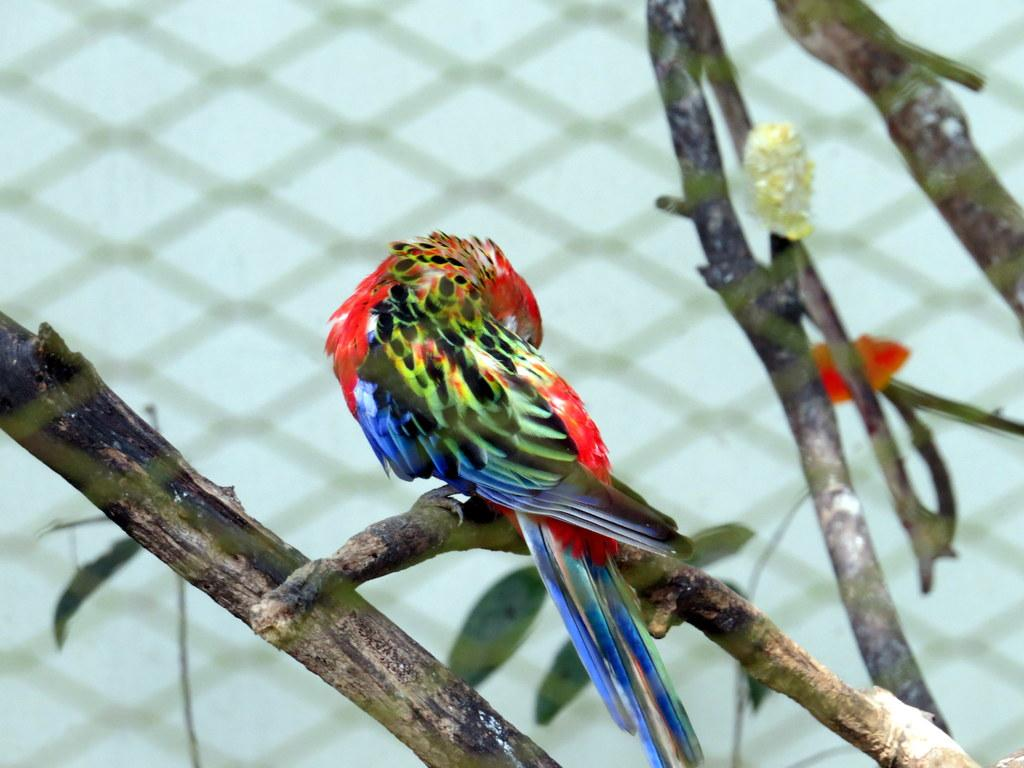What type of animal is in the image? There is a parrot in the image. Where is the parrot located in the image? The parrot is standing on a branch of a plant. What can be seen in the background of the image? There is a net in the background of the image. How would you describe the appearance of the parrot? The parrot is colorful. Who is the daughter of the parrot in the image? There is no mention of a daughter or any family relationships in the image. The image only features a parrot standing on a branch of a plant. 